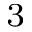Convert formula to latex. <formula><loc_0><loc_0><loc_500><loc_500>^ { 3 }</formula> 